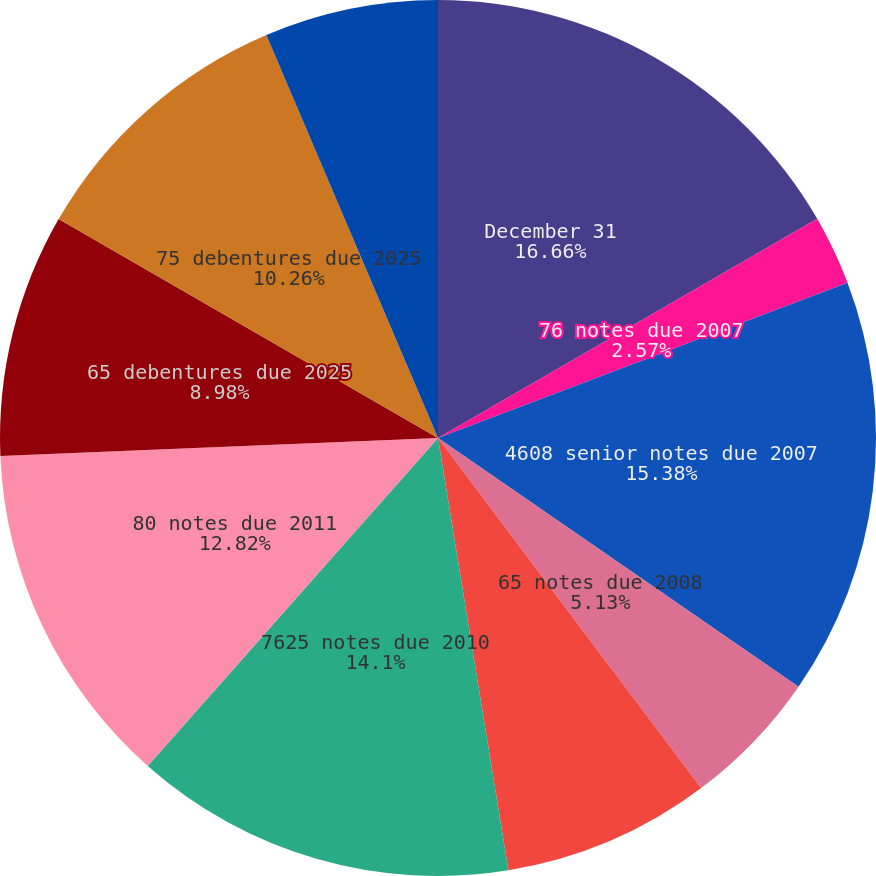<chart> <loc_0><loc_0><loc_500><loc_500><pie_chart><fcel>December 31<fcel>76 notes due 2007<fcel>4608 senior notes due 2007<fcel>65 notes due 2008<fcel>58 notes due 2008<fcel>7625 notes due 2010<fcel>80 notes due 2011<fcel>65 debentures due 2025<fcel>75 debentures due 2025<fcel>65 debentures due 2028<nl><fcel>16.66%<fcel>2.57%<fcel>15.38%<fcel>5.13%<fcel>7.69%<fcel>14.1%<fcel>12.82%<fcel>8.98%<fcel>10.26%<fcel>6.41%<nl></chart> 